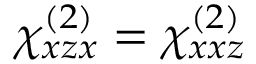Convert formula to latex. <formula><loc_0><loc_0><loc_500><loc_500>\chi _ { x z x } ^ { ( 2 ) } = \chi _ { x x z } ^ { ( 2 ) }</formula> 